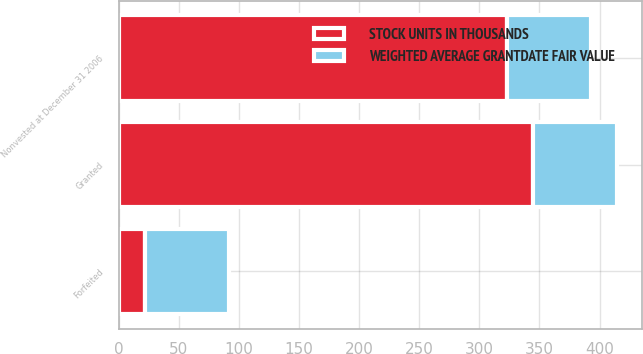Convert chart to OTSL. <chart><loc_0><loc_0><loc_500><loc_500><stacked_bar_chart><ecel><fcel>Granted<fcel>Forfeited<fcel>Nonvested at December 31 2006<nl><fcel>STOCK UNITS IN THOUSANDS<fcel>345<fcel>22<fcel>323<nl><fcel>WEIGHTED AVERAGE GRANTDATE FAIR VALUE<fcel>69.7<fcel>69.77<fcel>69.69<nl></chart> 